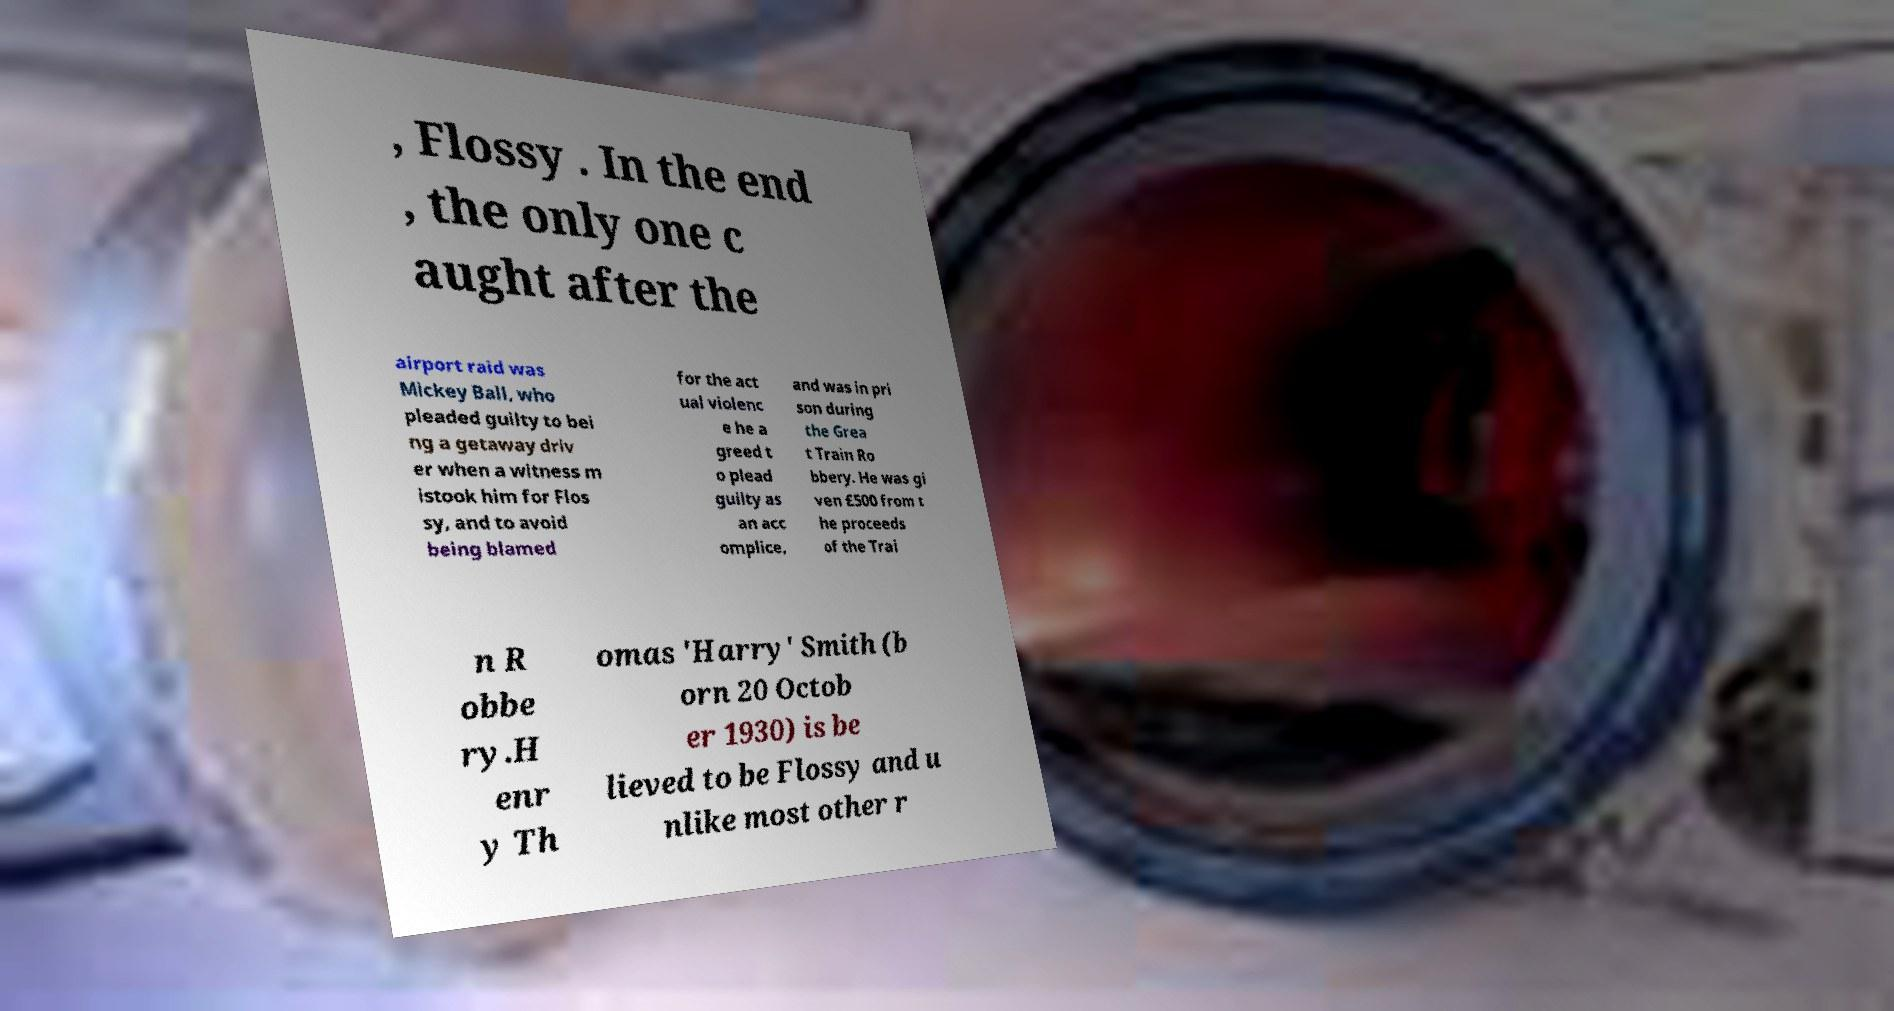I need the written content from this picture converted into text. Can you do that? , Flossy . In the end , the only one c aught after the airport raid was Mickey Ball, who pleaded guilty to bei ng a getaway driv er when a witness m istook him for Flos sy, and to avoid being blamed for the act ual violenc e he a greed t o plead guilty as an acc omplice, and was in pri son during the Grea t Train Ro bbery. He was gi ven £500 from t he proceeds of the Trai n R obbe ry.H enr y Th omas 'Harry' Smith (b orn 20 Octob er 1930) is be lieved to be Flossy and u nlike most other r 